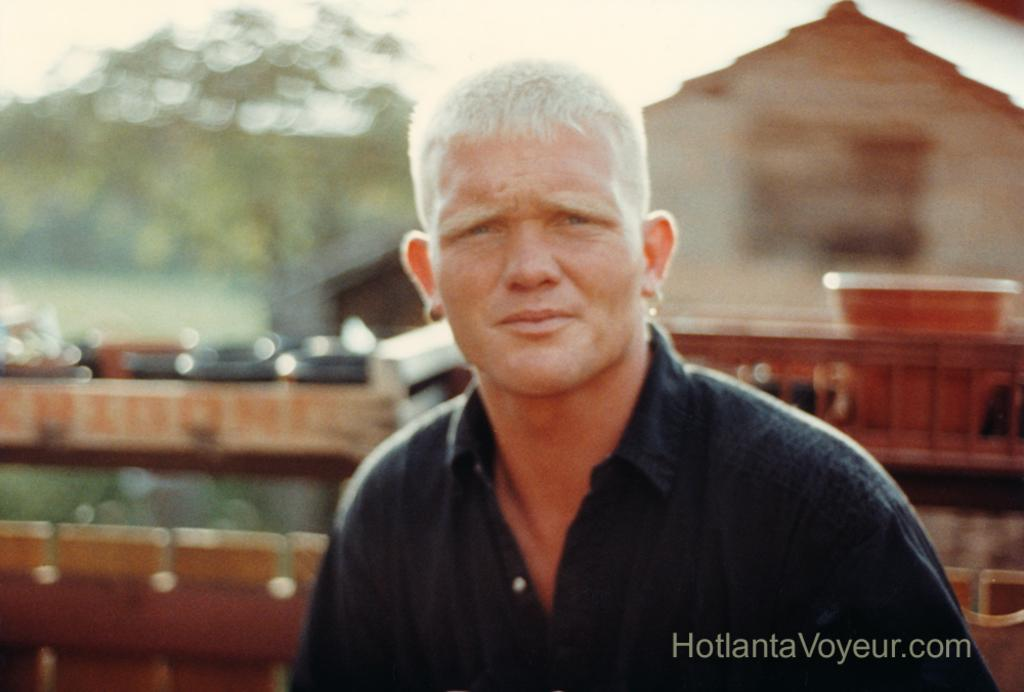Who or what is the main subject in the image? There is a person in the image. What is the person wearing? The person is wearing a black shirt. What can be seen behind the person? There is a tree behind the person. What type of structure is visible in the image? There is a building in the image. What type of soap is the person holding in the image? There is no soap present in the image; the person is not holding anything. Can you tell me the color of the berries on the tree behind the person? There are no berries visible on the tree behind the person in the image. 